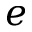<formula> <loc_0><loc_0><loc_500><loc_500>e</formula> 